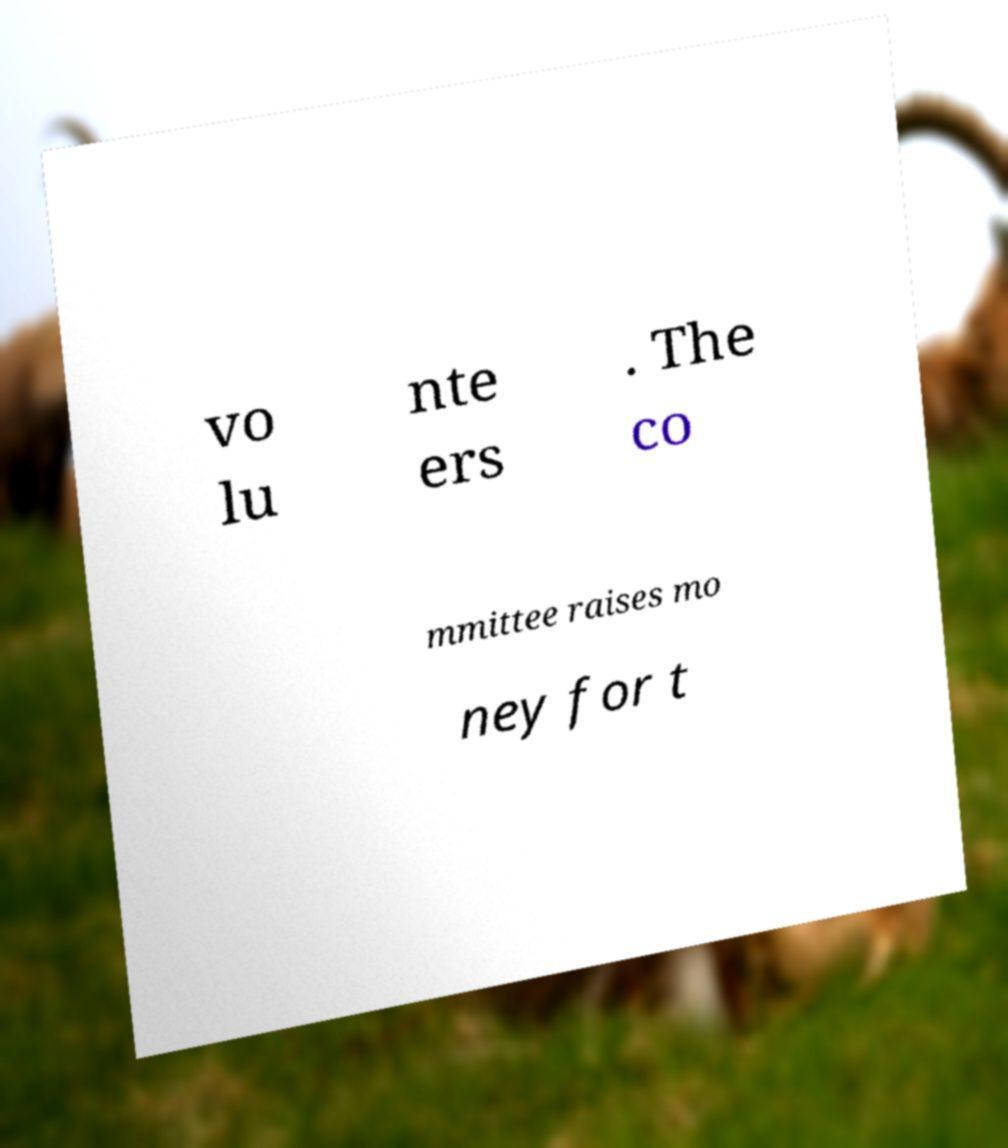Can you accurately transcribe the text from the provided image for me? vo lu nte ers . The co mmittee raises mo ney for t 